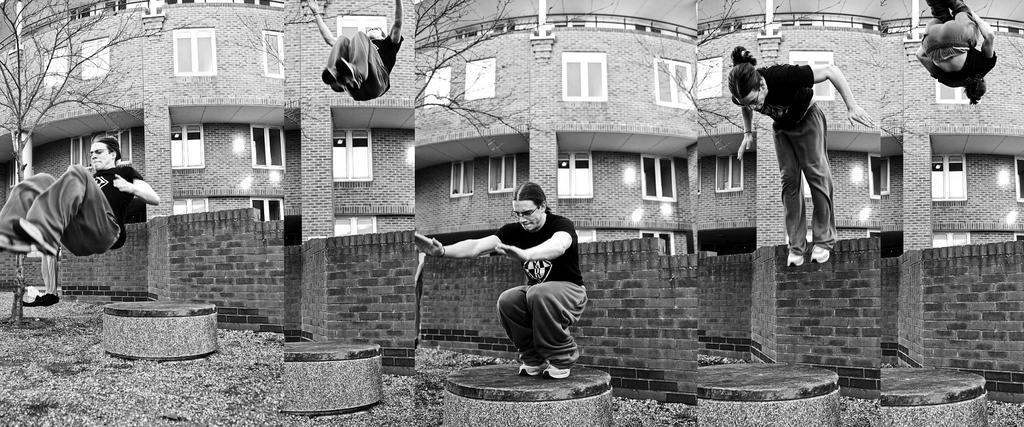Describe this image in one or two sentences. It is a collage picture, in the picture a man is doing jumping. Behind him there is a wall and tree and building. 